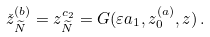Convert formula to latex. <formula><loc_0><loc_0><loc_500><loc_500>\check { z } _ { \widetilde { N } } ^ { ( b ) } = z _ { \widetilde { N } } ^ { c _ { 2 } } = G ( \varepsilon a _ { 1 } , z _ { 0 } ^ { ( a ) } , z ) \, .</formula> 